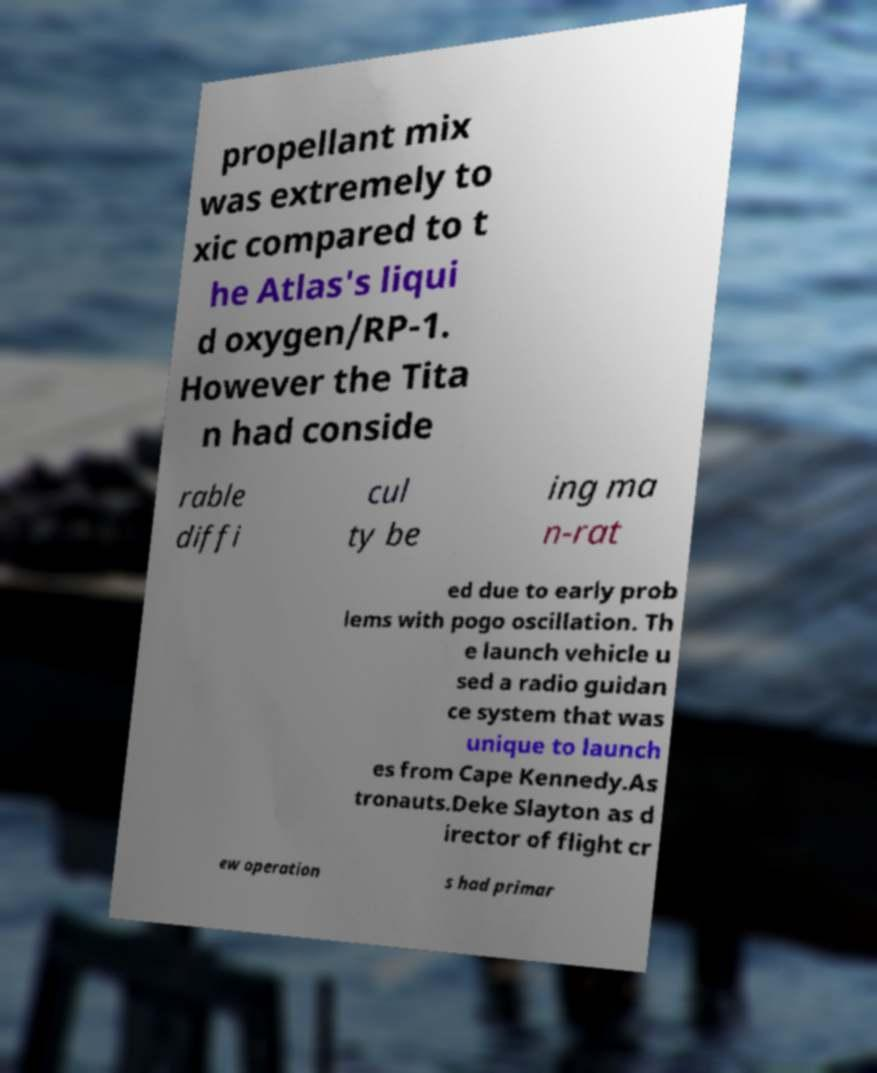Could you assist in decoding the text presented in this image and type it out clearly? propellant mix was extremely to xic compared to t he Atlas's liqui d oxygen/RP-1. However the Tita n had conside rable diffi cul ty be ing ma n-rat ed due to early prob lems with pogo oscillation. Th e launch vehicle u sed a radio guidan ce system that was unique to launch es from Cape Kennedy.As tronauts.Deke Slayton as d irector of flight cr ew operation s had primar 